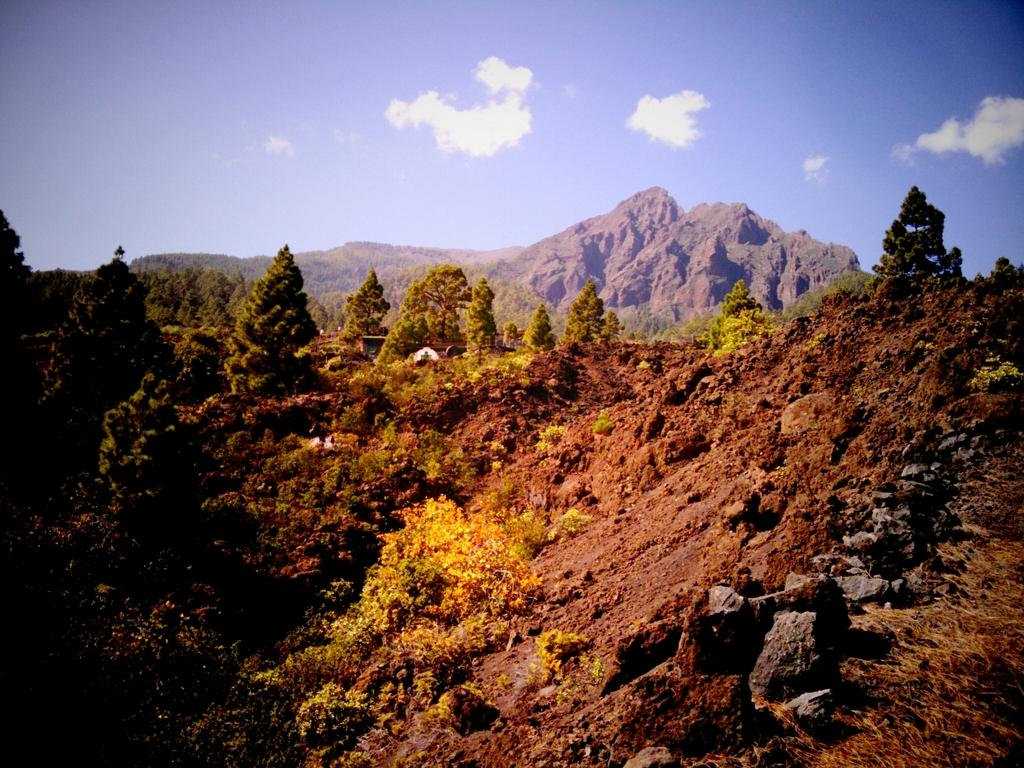What type of vegetation can be seen in the image? There are trees in the image. What type of ground cover is present in the image? There is grass in the image. What type of objects are on the ground in the image? There are stones on the ground in the image. What can be seen in the distance in the image? There are mountains in the background of the image. What is visible in the sky in the background of the image? There are clouds in the sky in the background of the image. How much sugar is present in the image? There is no sugar present in the image, as it features natural elements such as trees, grass, stones, mountains, and clouds. 